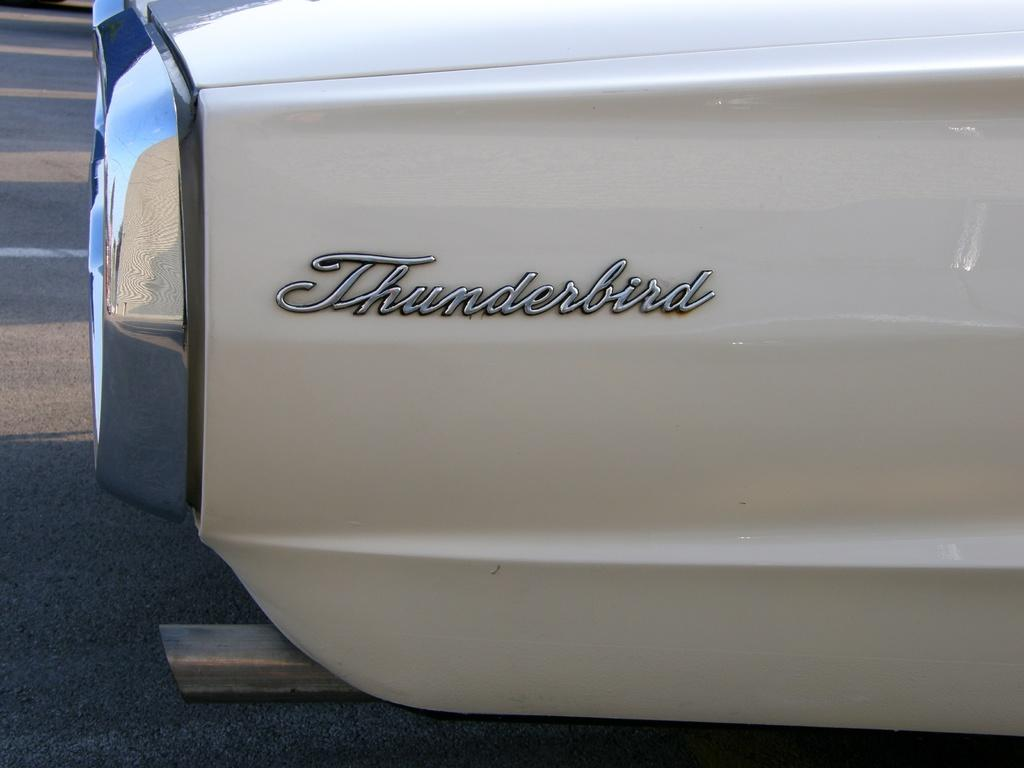What is the color of the main object in the image? The main object in the image is white. What can be seen on the white object? There is writing on the white object. What type of whip is being used to control the temper of the object in the image? There is no whip or indication of temper in the image; it only features a white object with writing on it. 